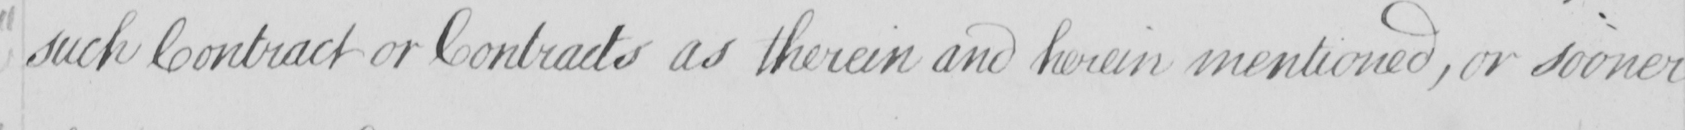Please provide the text content of this handwritten line. such Contract or Contracts as therein and herein mentioned , or sooner 